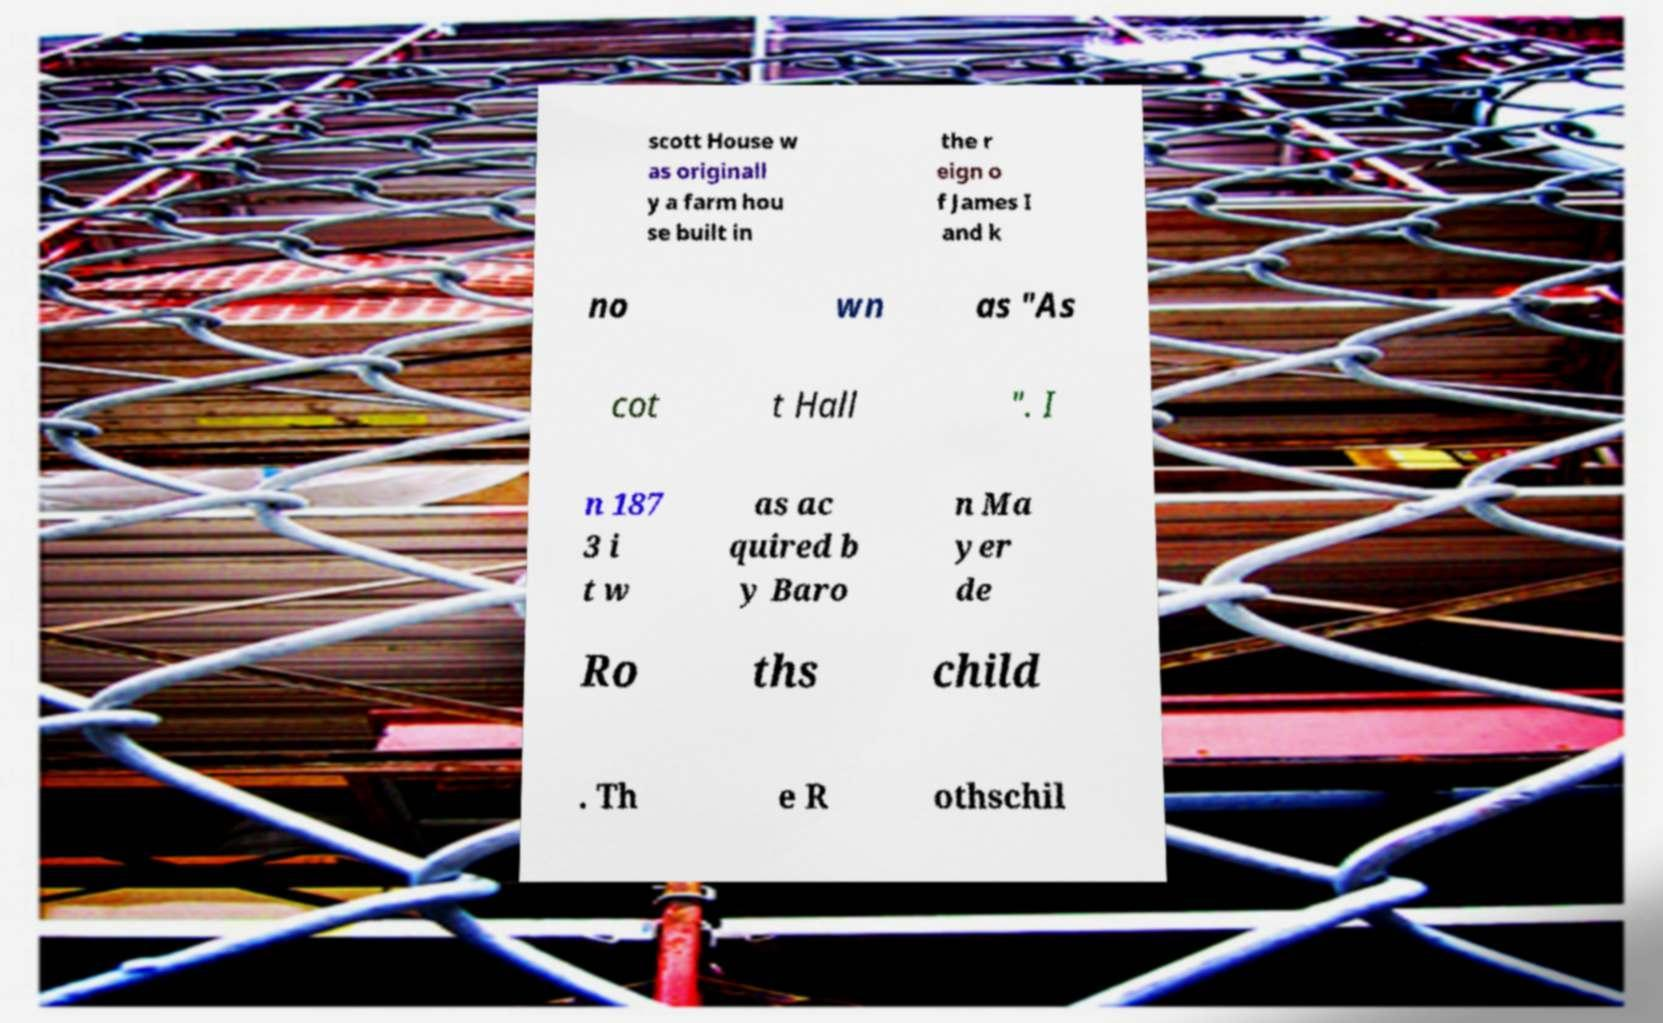What messages or text are displayed in this image? I need them in a readable, typed format. scott House w as originall y a farm hou se built in the r eign o f James I and k no wn as "As cot t Hall ". I n 187 3 i t w as ac quired b y Baro n Ma yer de Ro ths child . Th e R othschil 